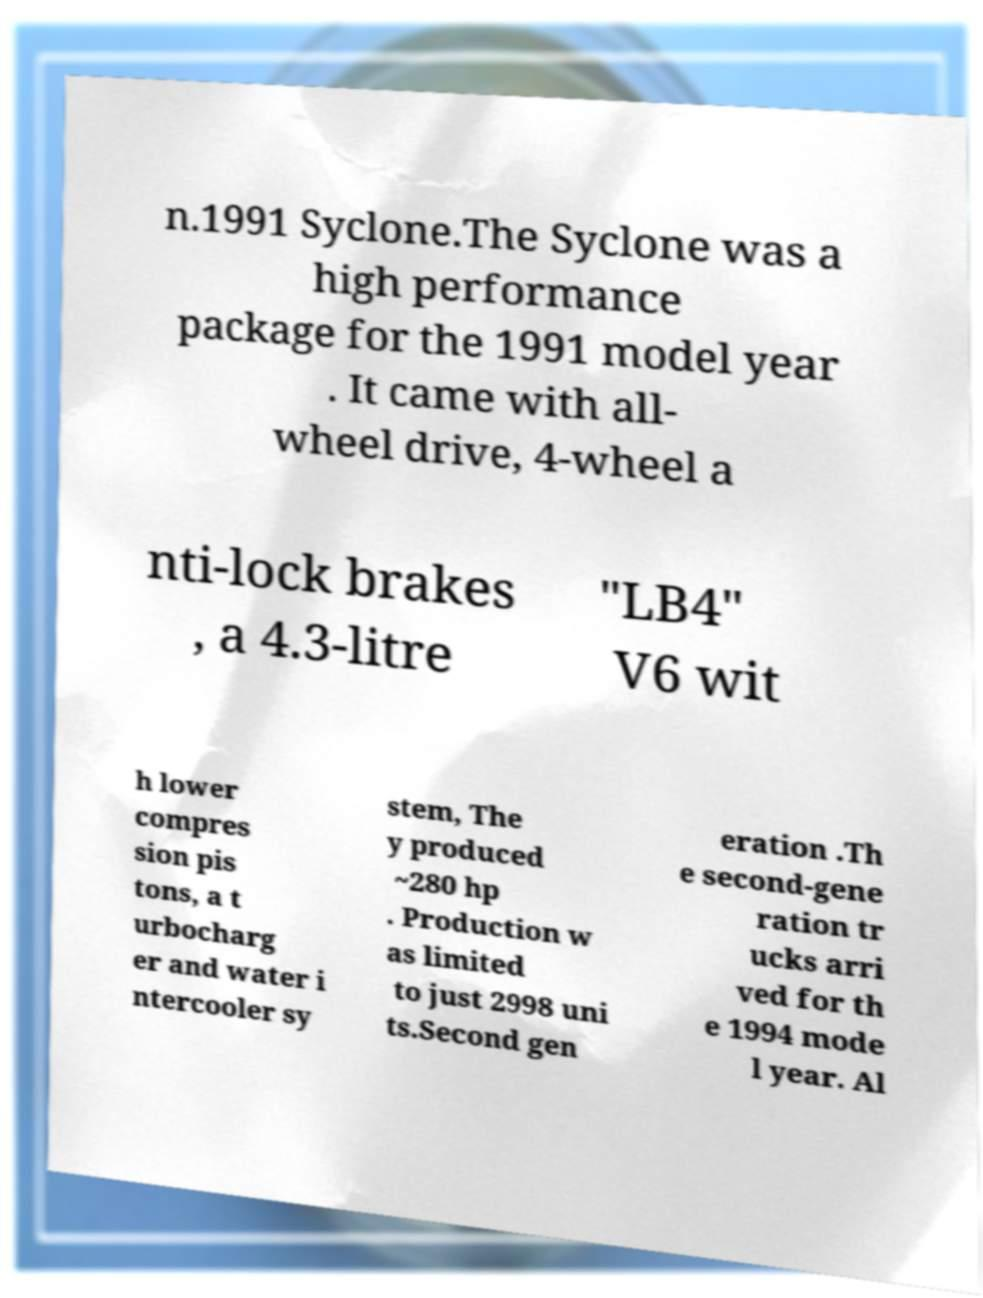For documentation purposes, I need the text within this image transcribed. Could you provide that? n.1991 Syclone.The Syclone was a high performance package for the 1991 model year . It came with all- wheel drive, 4-wheel a nti-lock brakes , a 4.3-litre "LB4" V6 wit h lower compres sion pis tons, a t urbocharg er and water i ntercooler sy stem, The y produced ~280 hp . Production w as limited to just 2998 uni ts.Second gen eration .Th e second-gene ration tr ucks arri ved for th e 1994 mode l year. Al 